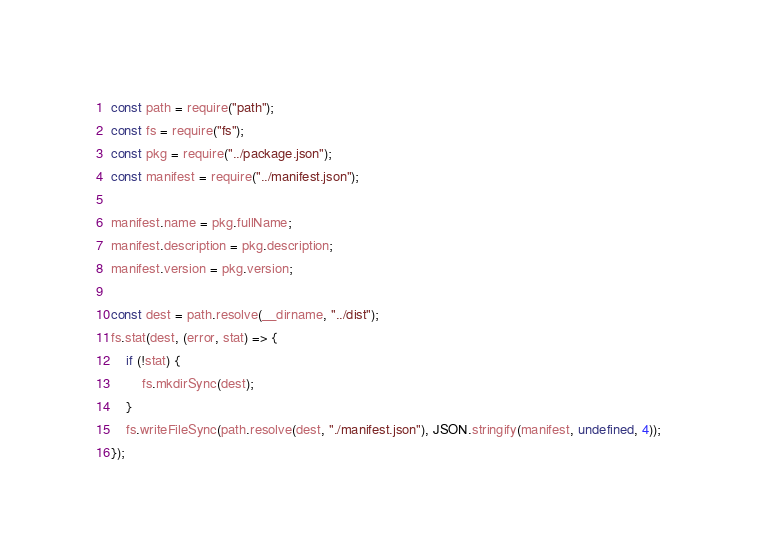Convert code to text. <code><loc_0><loc_0><loc_500><loc_500><_JavaScript_>const path = require("path");
const fs = require("fs");
const pkg = require("../package.json");
const manifest = require("../manifest.json");

manifest.name = pkg.fullName;
manifest.description = pkg.description;
manifest.version = pkg.version;

const dest = path.resolve(__dirname, "../dist");
fs.stat(dest, (error, stat) => {
    if (!stat) {
        fs.mkdirSync(dest);
    }
    fs.writeFileSync(path.resolve(dest, "./manifest.json"), JSON.stringify(manifest, undefined, 4));
});
</code> 